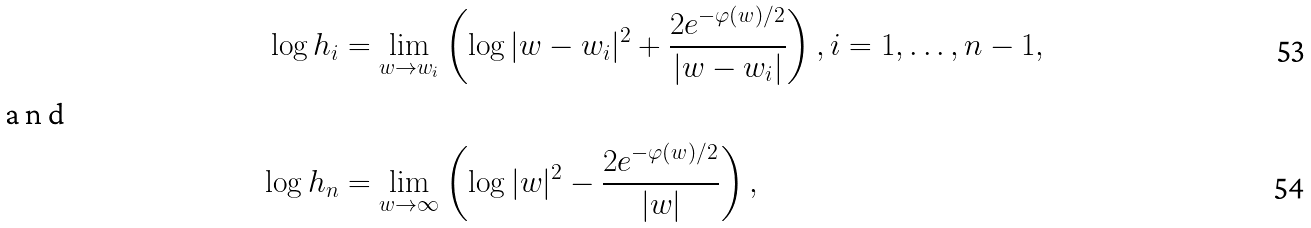Convert formula to latex. <formula><loc_0><loc_0><loc_500><loc_500>\log h _ { i } & = \lim _ { w \rightarrow w _ { i } } \left ( \log | w - w _ { i } | ^ { 2 } + \frac { 2 e ^ { - \varphi ( w ) / 2 } } { | w - w _ { i } | } \right ) , i = 1 , \dots , n - 1 , \\ \intertext { a n d } \log h _ { n } & = \lim _ { w \rightarrow \infty } \left ( \log | w | ^ { 2 } - \frac { 2 e ^ { - \varphi ( w ) / 2 } } { | w | } \right ) ,</formula> 